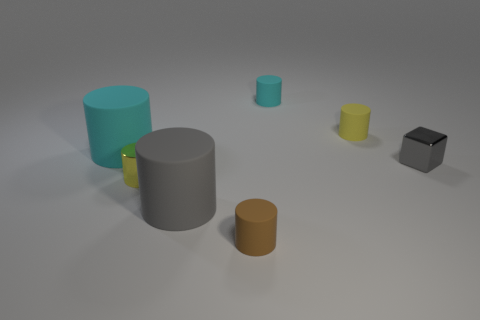There is a large object that is in front of the block; does it have the same color as the block?
Provide a succinct answer. Yes. What number of big matte things have the same color as the tiny block?
Provide a succinct answer. 1. How many things are either big rubber cylinders behind the metallic cube or large red rubber balls?
Keep it short and to the point. 1. What is the big cyan cylinder made of?
Offer a very short reply. Rubber. Is the cube the same size as the yellow matte cylinder?
Keep it short and to the point. Yes. What number of cylinders are either tiny gray metallic things or big purple matte things?
Provide a short and direct response. 0. What is the color of the shiny cylinder behind the large rubber cylinder in front of the yellow metal cylinder?
Provide a succinct answer. Yellow. Are there fewer gray rubber cylinders that are behind the metal block than cyan rubber cylinders to the left of the brown rubber cylinder?
Provide a short and direct response. Yes. Does the yellow shiny cylinder have the same size as the matte cylinder that is in front of the gray matte cylinder?
Ensure brevity in your answer.  Yes. There is a rubber object that is both behind the tiny brown thing and in front of the cube; what is its shape?
Provide a short and direct response. Cylinder. 